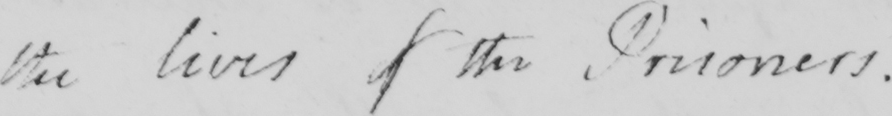Can you read and transcribe this handwriting? the lives of the Prisoners . 